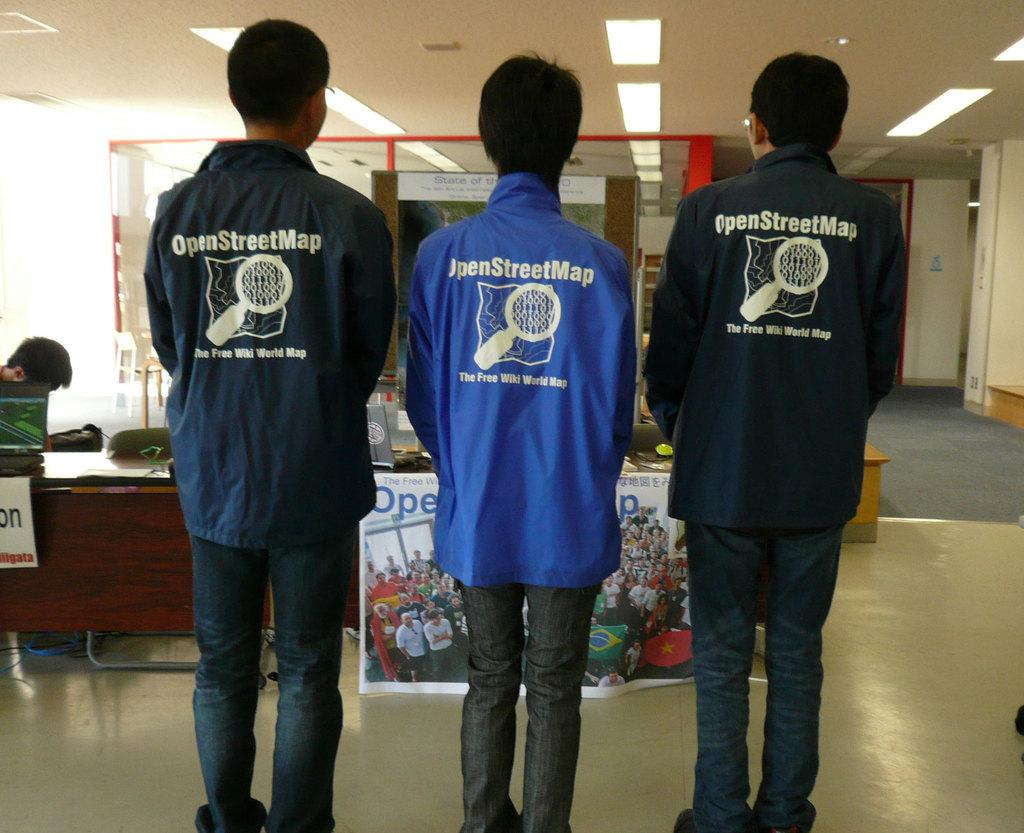<image>
Present a compact description of the photo's key features. Several young men wear windbreakers from the OpenStreetMap project. 